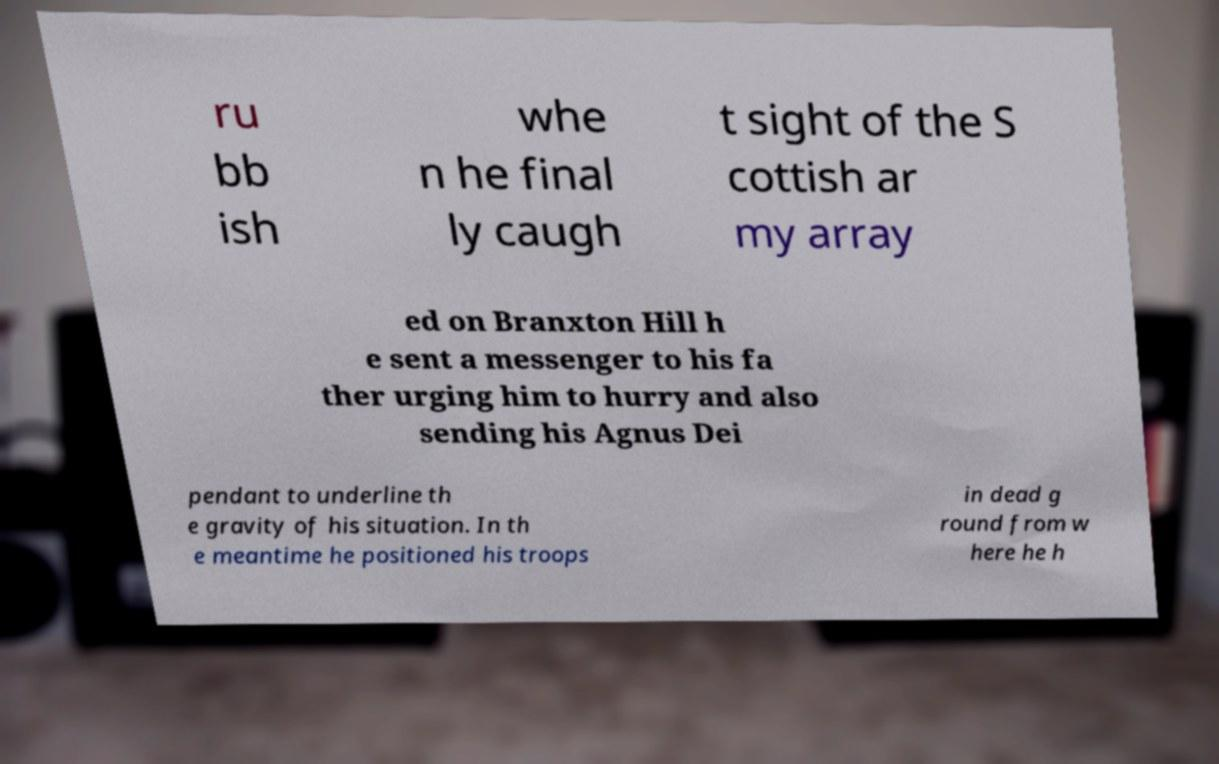Can you read and provide the text displayed in the image?This photo seems to have some interesting text. Can you extract and type it out for me? ru bb ish whe n he final ly caugh t sight of the S cottish ar my array ed on Branxton Hill h e sent a messenger to his fa ther urging him to hurry and also sending his Agnus Dei pendant to underline th e gravity of his situation. In th e meantime he positioned his troops in dead g round from w here he h 